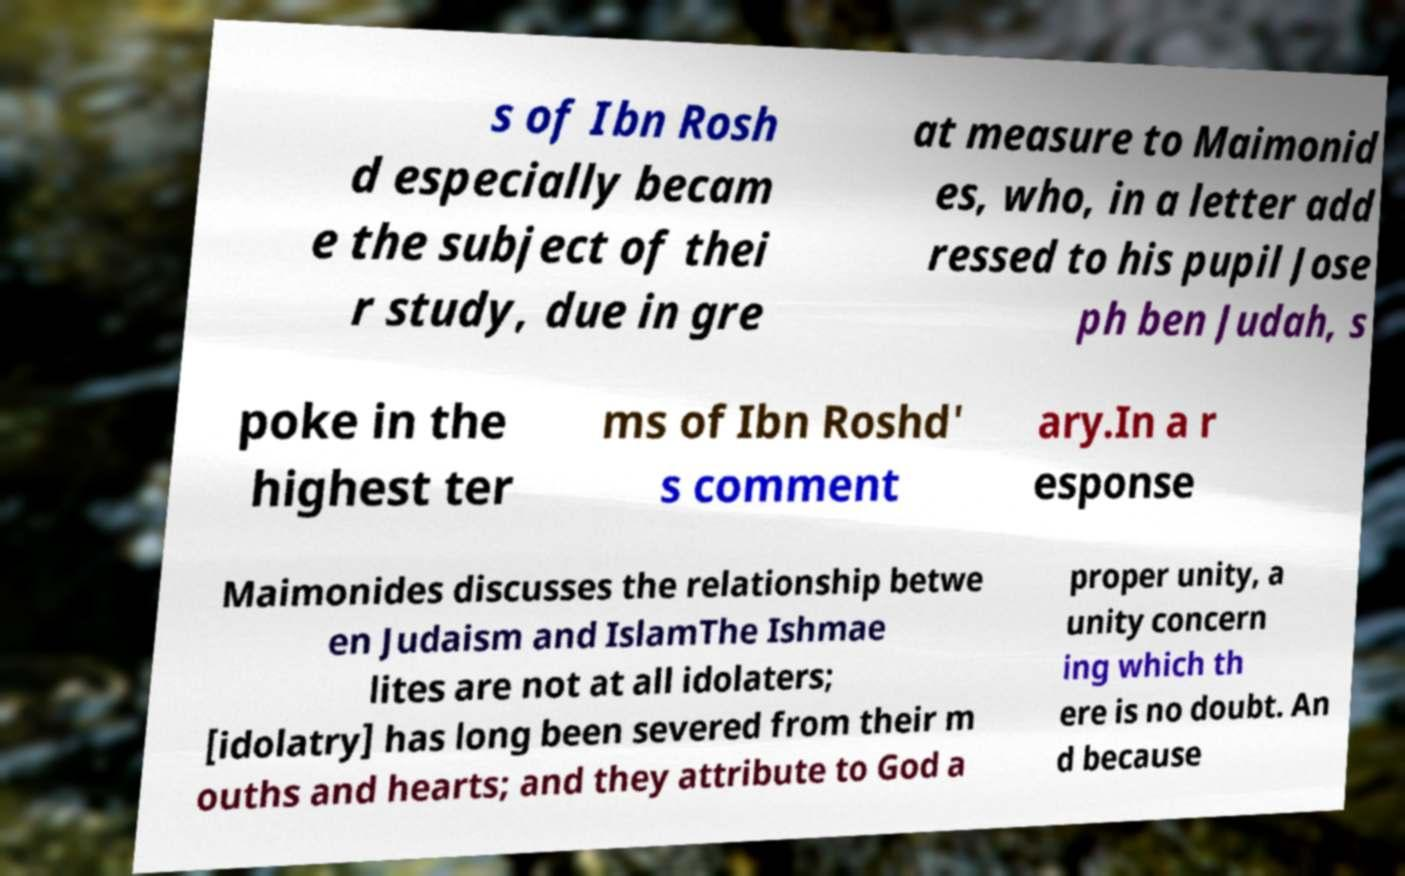Can you accurately transcribe the text from the provided image for me? s of Ibn Rosh d especially becam e the subject of thei r study, due in gre at measure to Maimonid es, who, in a letter add ressed to his pupil Jose ph ben Judah, s poke in the highest ter ms of Ibn Roshd' s comment ary.In a r esponse Maimonides discusses the relationship betwe en Judaism and IslamThe Ishmae lites are not at all idolaters; [idolatry] has long been severed from their m ouths and hearts; and they attribute to God a proper unity, a unity concern ing which th ere is no doubt. An d because 